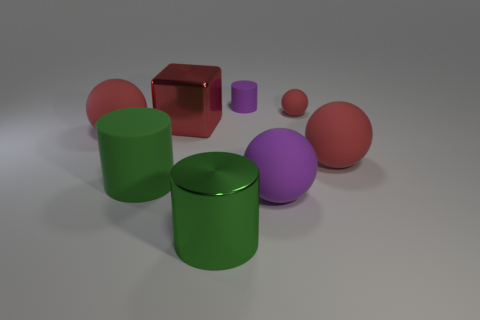The metallic object that is in front of the large green object behind the purple sphere is what color?
Offer a terse response. Green. There is a thing that is the same color as the small rubber cylinder; what material is it?
Offer a very short reply. Rubber. The large sphere that is to the right of the big purple thing is what color?
Provide a short and direct response. Red. There is a green cylinder left of the green shiny cylinder; is it the same size as the block?
Give a very brief answer. Yes. What is the size of the ball that is the same color as the tiny rubber cylinder?
Offer a terse response. Large. Is there a red sphere of the same size as the red cube?
Provide a succinct answer. Yes. There is a small rubber ball that is right of the red metal thing; does it have the same color as the large matte object right of the small red rubber object?
Offer a very short reply. Yes. Is there a small sphere that has the same color as the small cylinder?
Give a very brief answer. No. What number of other objects are there of the same shape as the green rubber object?
Offer a very short reply. 2. What is the shape of the large shiny thing in front of the green matte thing?
Provide a succinct answer. Cylinder. 